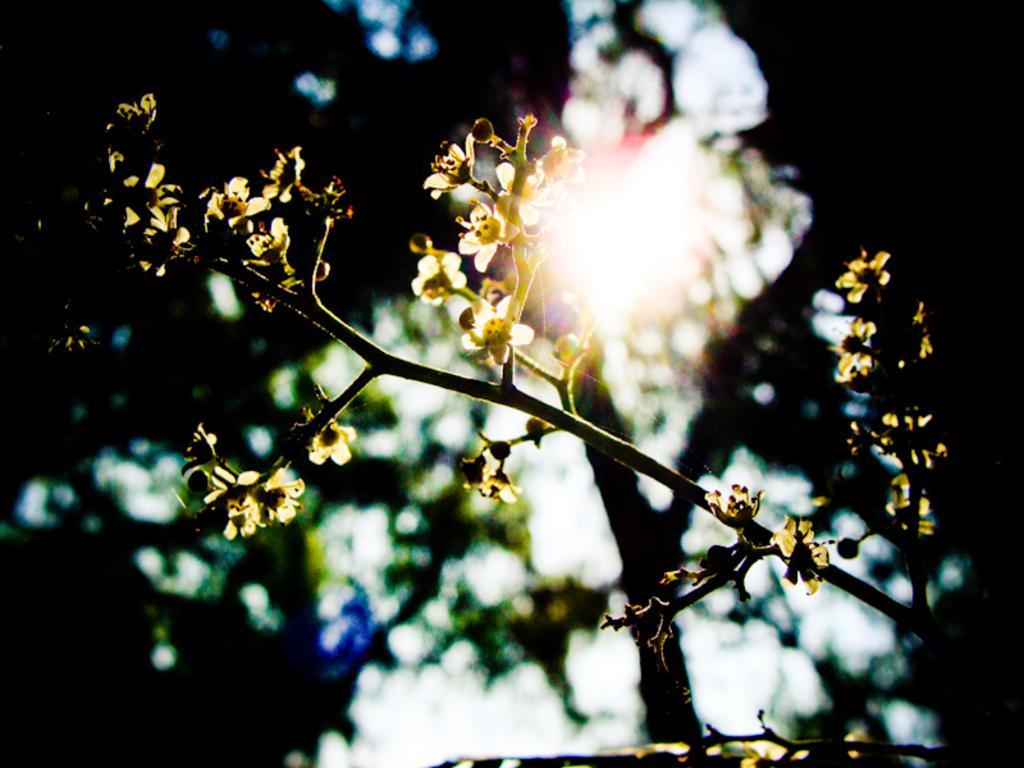Can you describe this image briefly? In this picture there are flowers on the plant. At the back there is a tree. At the top there is sky and there is a sun. 